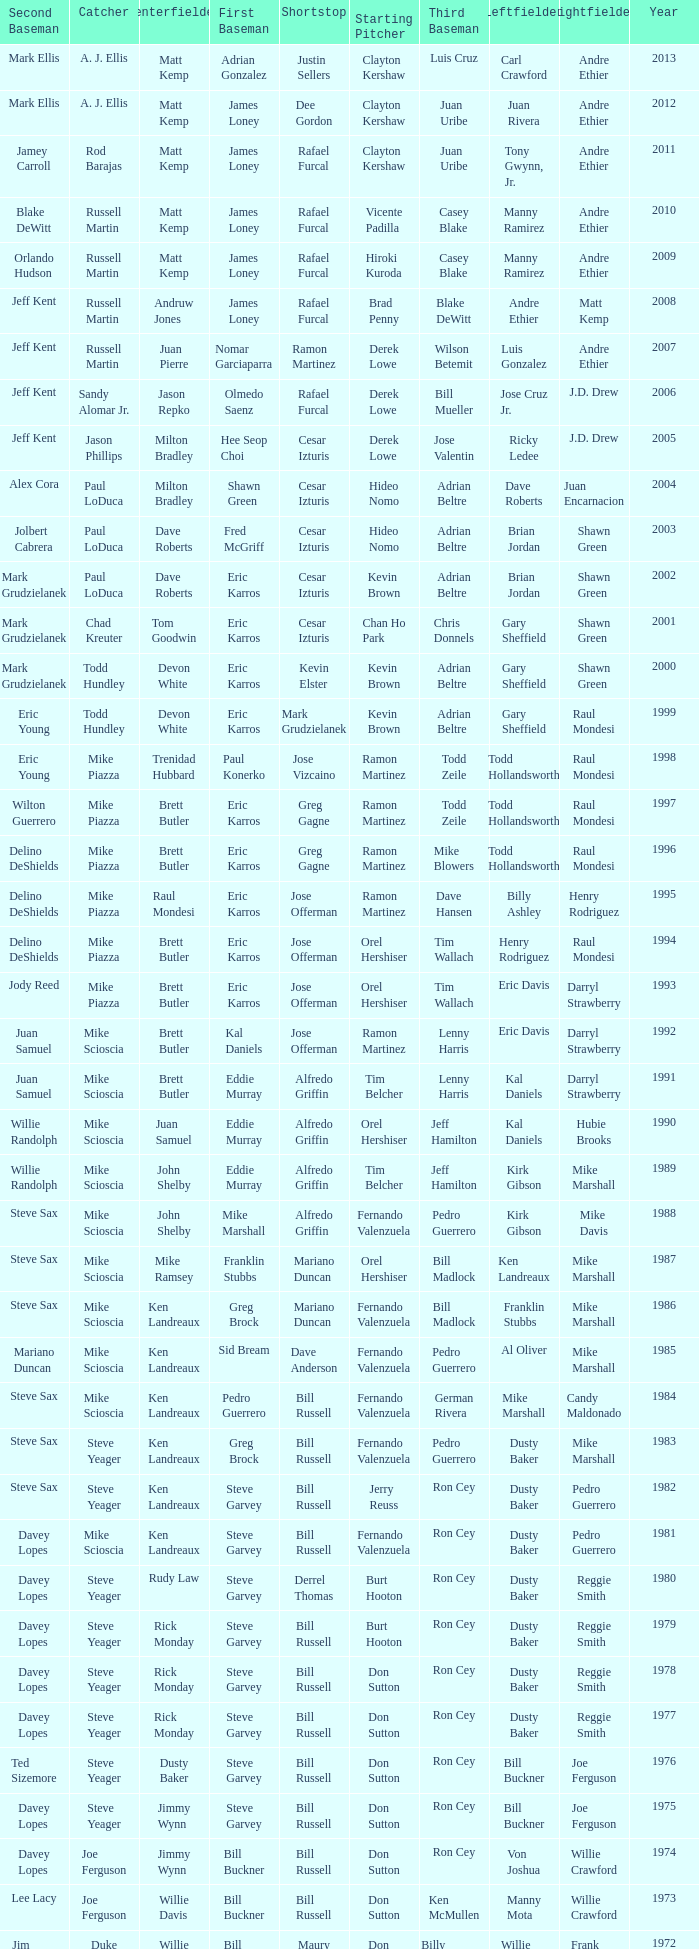Who was the SS when jim lefebvre was at 2nd, willie davis at CF, and don drysdale was the SP. Maury Wills. 